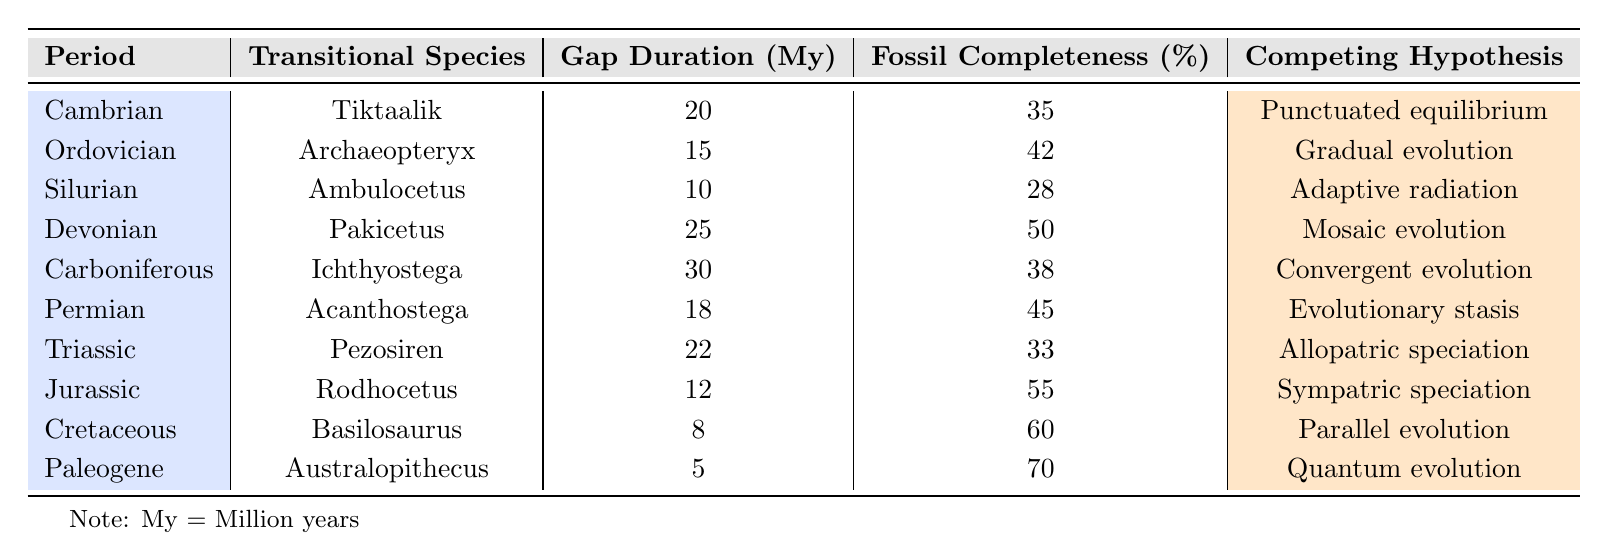What transitional species is associated with the Triassic period? In the table, under the "Triassic" period, the transitional species listed is "Pezosiren."
Answer: Pezosiren What is the gap duration in million years for the species Australopithecus? The table lists the gap duration for "Australopithecus" in the "Paleogene" period as 5 million years.
Answer: 5 million years Which period has the highest fossil completeness percentage? By comparing the fossil completeness percentages in the table, "Australopithecus" in the "Paleogene" period has the highest percentage at 70%.
Answer: Paleogene Calculate the average gap duration for the periods listed in the table. To find the average gap duration, sum all the gap durations: (20 + 15 + 10 + 25 + 30 + 18 + 22 + 12 + 8 + 5) =  20.5. There are 10 periods, so the average is 205/10 = 20.5 million years.
Answer: 20.5 million years Is the fossil completeness for the Cretaceous period greater than that for the Devonian period? The fossil completeness for the "Cretaceous" period is 60%, whereas for the "Devonian" period, it is 50%. Thus, 60% is greater than 50%.
Answer: Yes Which species has the longest gap duration, and during which period does it occur? The longest gap duration is 30 million years, associated with the species "Ichthyostega," which occurs during the "Carboniferous" period.
Answer: Ichthyostega, Carboniferous What is the difference in fossil completeness percentage between the Silurian and the Permian periods? The fossil completeness for the "Silurian" period is 28%, while for the "Permian" period, it is 45%. The difference is 45 - 28 = 17%.
Answer: 17% Can we say that "Adaptive radiation" is the competing hypothesis for the species with the shortest gap duration? The species with the shortest gap duration is "Australopithecus," which is categorized under "Quantum evolution," not "Adaptive radiation." Thus, the statement is false.
Answer: No Which competing hypothesis corresponds to the highest fossil completeness percentage, and what is that percentage? The highest fossil completeness percentage is 70%, which corresponds to "Quantum evolution" for "Australopithecus" in the "Paleogene" period.
Answer: Quantum evolution, 70% How many periods have a gap duration of more than 20 million years? From the table, we can see that the periods with gap durations over 20 million years are "Cambrian" (20), "Devonian" (25), "Carboniferous" (30), and "Triassic" (22). This totals 4 periods.
Answer: 4 periods 